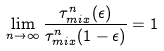Convert formula to latex. <formula><loc_0><loc_0><loc_500><loc_500>\lim _ { n \rightarrow \infty } \frac { \tau _ { m i x } ^ { n } ( \epsilon ) } { \tau _ { m i x } ^ { n } ( 1 - \epsilon ) } = 1</formula> 